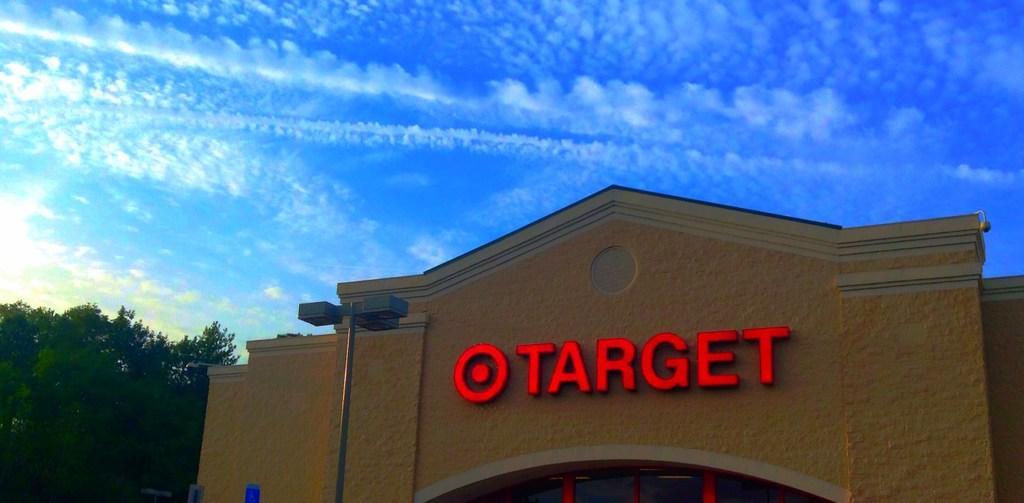In one or two sentences, can you explain what this image depicts? In this image we can see a building with windows. We can also see some lights to a pole. On the backside we can see a group of trees and the sky which looks cloudy. 